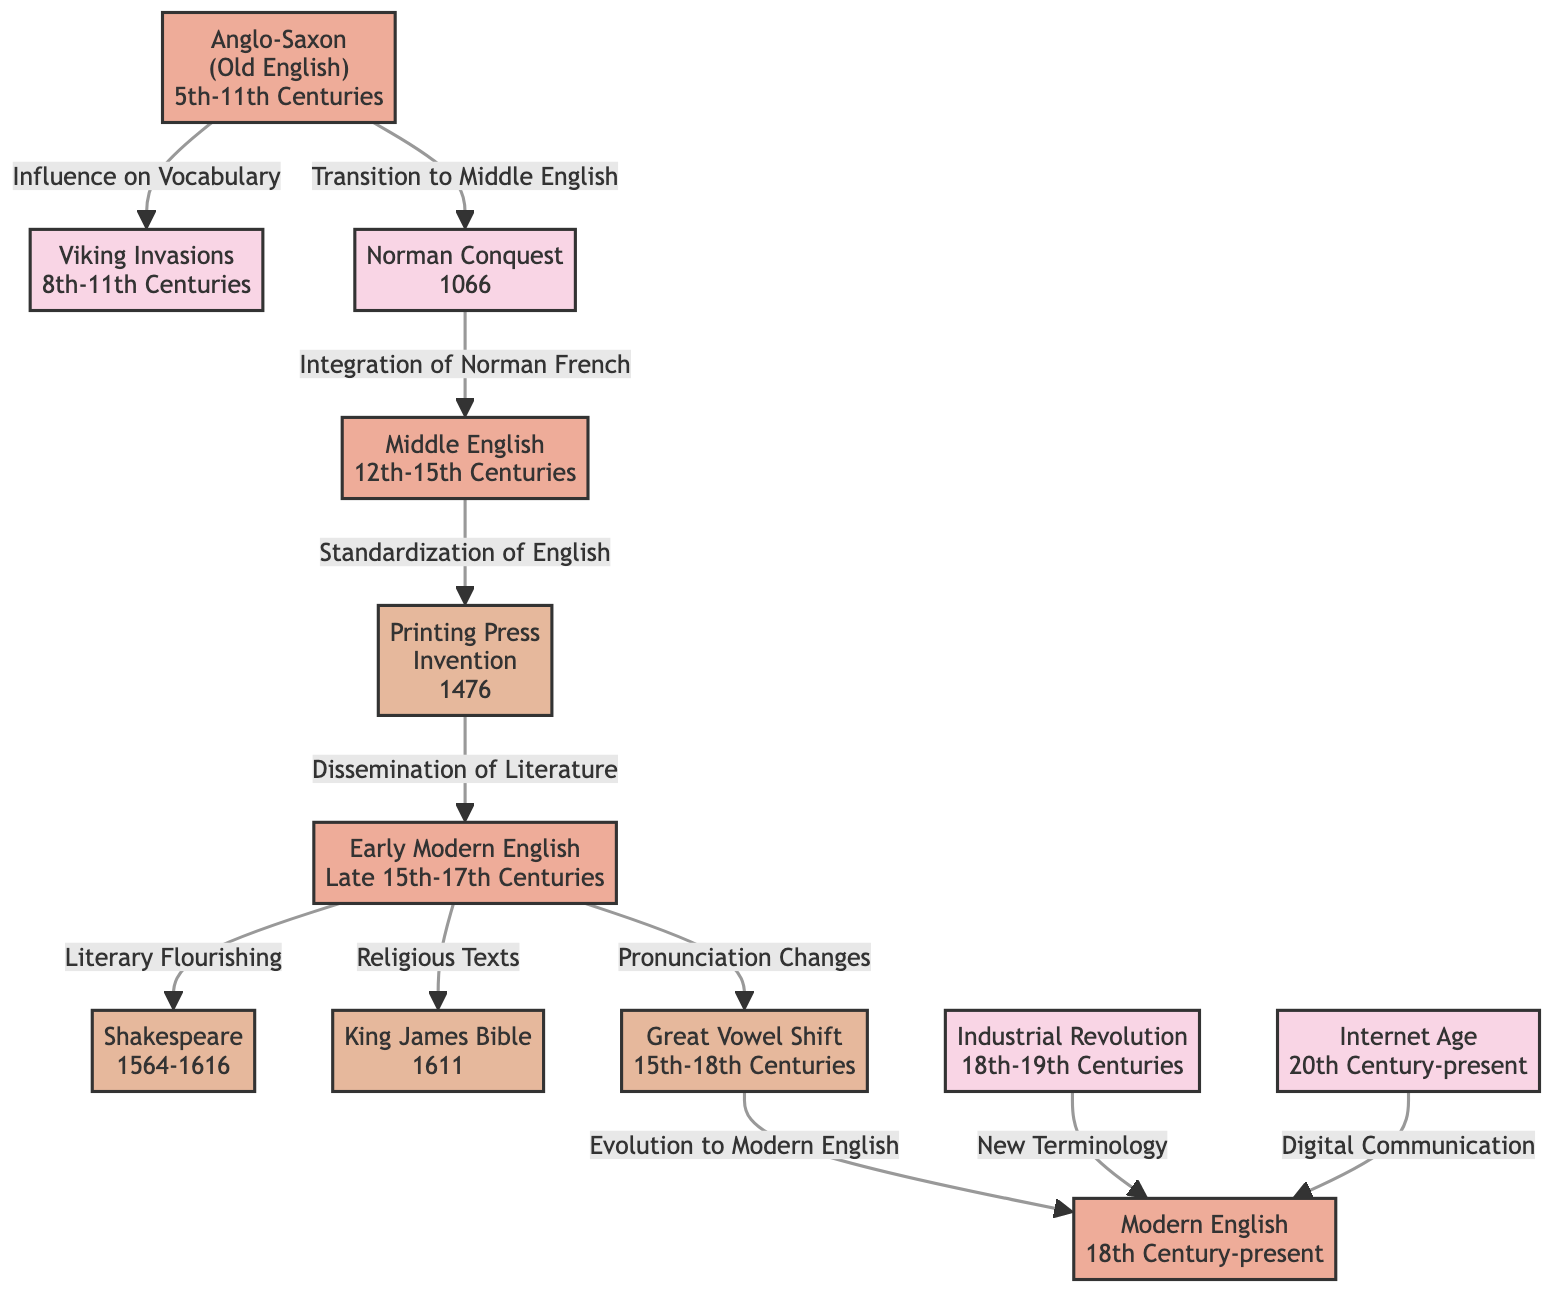What time period does Anglo-Saxon (Old English) cover? The diagram specifically states that the Anglo-Saxon period spans from the 5th to the 11th centuries.
Answer: 5th-11th Centuries What historical event led to the transition to Middle English? The diagram indicates that the Norman Conquest, occurring in 1066, was a significant event that transitioned the English language from Anglo-Saxon to Middle English.
Answer: Norman Conquest How many stages of the English language are represented in the diagram? By counting the language nodes presented in the diagram, there are four distinct stages identified: Anglo-Saxon, Middle English, Early Modern English, and Modern English.
Answer: 4 What event is linked to the integration of Norman French? According to the diagram, the integration of Norman French into the English language occurred after the Norman Conquest, which connects directly to the transition to Middle English.
Answer: Norman Conquest What was the impact of the Printing Press on the English language? The diagram illustrates that the invention of the Printing Press facilitated the standardization of English, marking an important change in the language's development.
Answer: Standardization of English Which literary figure is associated with the Early Modern English stage? The diagram explicitly names Shakespeare as a prominent literary figure connected to the Early Modern English period.
Answer: Shakespeare How did the Great Vowel Shift affect the evolution of Modern English? The diagram shows a direct path from the Great Vowel Shift to the evolution of Modern English, indicating that this phonetic change was crucial in the development of the language.
Answer: Evolution to Modern English What historical event correlates with the emergence of new terminology in Modern English? The Industrial Revolution, as noted in the diagram, is directly associated with the emergence of new terminology in the English language during its development.
Answer: Industrial Revolution What does the Internet Age contribute to Modern English? The diagram connects the Internet Age to Modern English through digital communication, highlighting its influence on the language in contemporary times.
Answer: Digital Communication 